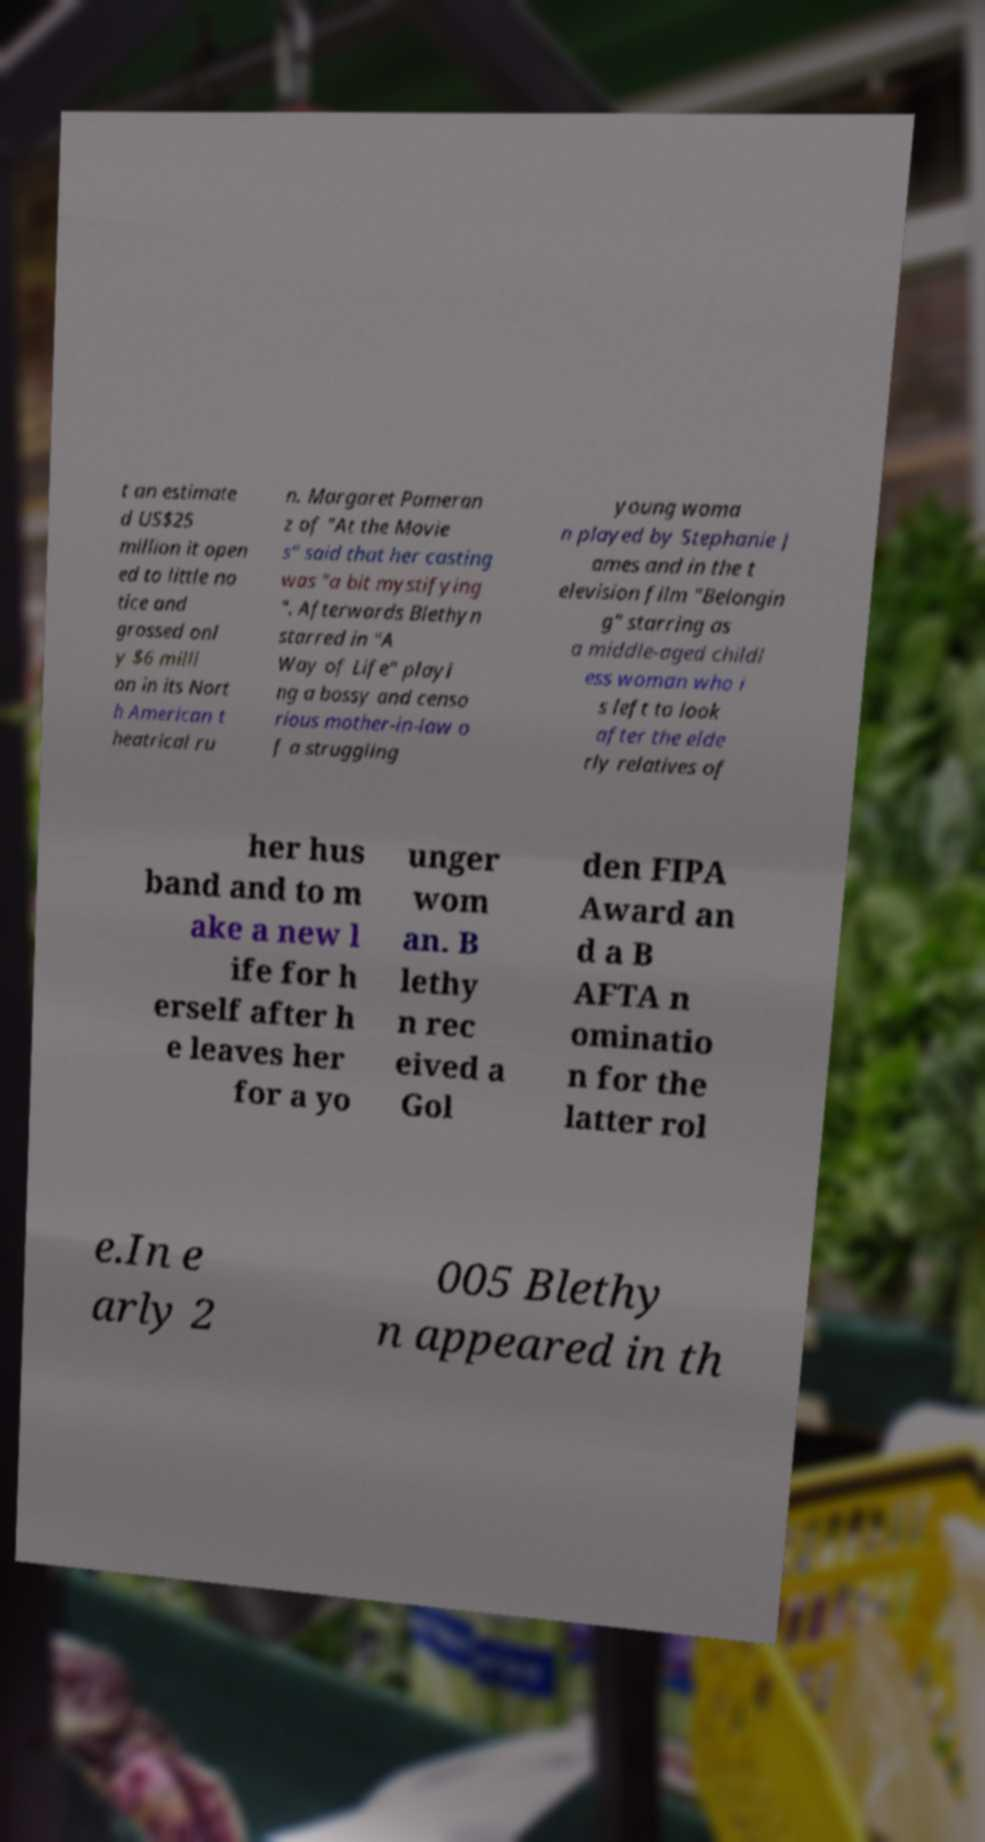For documentation purposes, I need the text within this image transcribed. Could you provide that? t an estimate d US$25 million it open ed to little no tice and grossed onl y $6 milli on in its Nort h American t heatrical ru n. Margaret Pomeran z of "At the Movie s" said that her casting was "a bit mystifying ". Afterwards Blethyn starred in "A Way of Life" playi ng a bossy and censo rious mother-in-law o f a struggling young woma n played by Stephanie J ames and in the t elevision film "Belongin g" starring as a middle-aged childl ess woman who i s left to look after the elde rly relatives of her hus band and to m ake a new l ife for h erself after h e leaves her for a yo unger wom an. B lethy n rec eived a Gol den FIPA Award an d a B AFTA n ominatio n for the latter rol e.In e arly 2 005 Blethy n appeared in th 